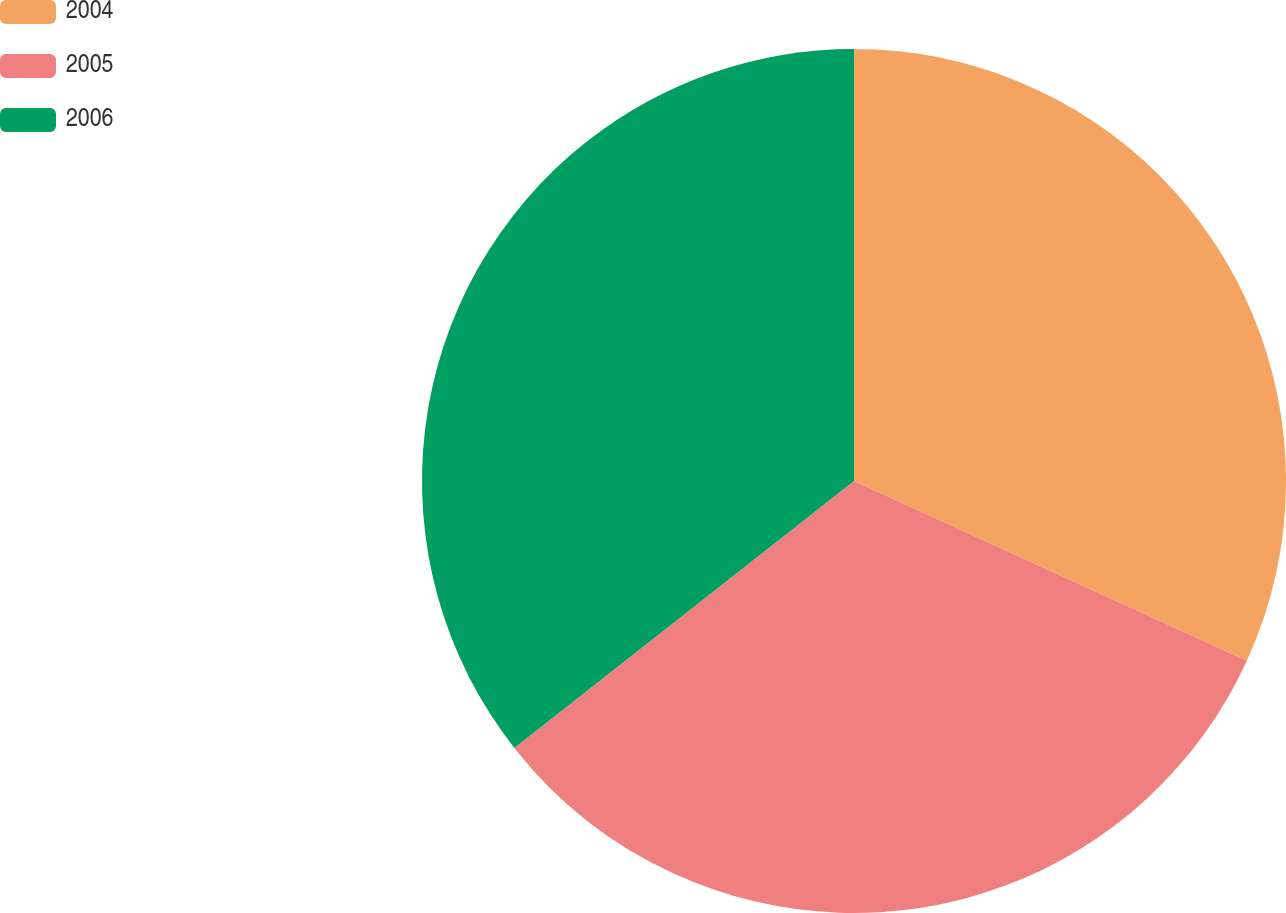Convert chart. <chart><loc_0><loc_0><loc_500><loc_500><pie_chart><fcel>2004<fcel>2005<fcel>2006<nl><fcel>31.83%<fcel>32.57%<fcel>35.6%<nl></chart> 